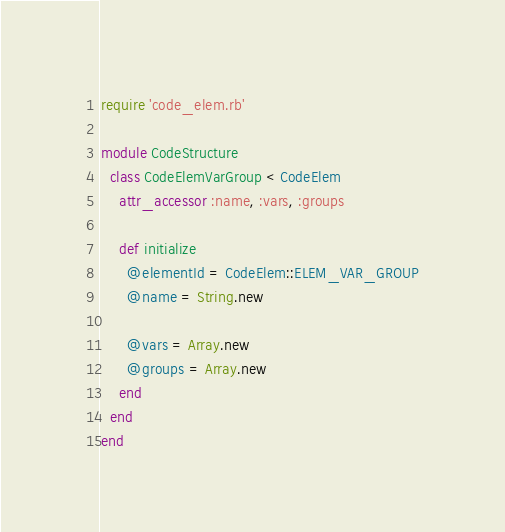Convert code to text. <code><loc_0><loc_0><loc_500><loc_500><_Ruby_>require 'code_elem.rb'

module CodeStructure
  class CodeElemVarGroup < CodeElem
    attr_accessor :name, :vars, :groups

    def initialize
      @elementId = CodeElem::ELEM_VAR_GROUP
      @name = String.new

      @vars = Array.new
      @groups = Array.new
    end
  end
end
</code> 